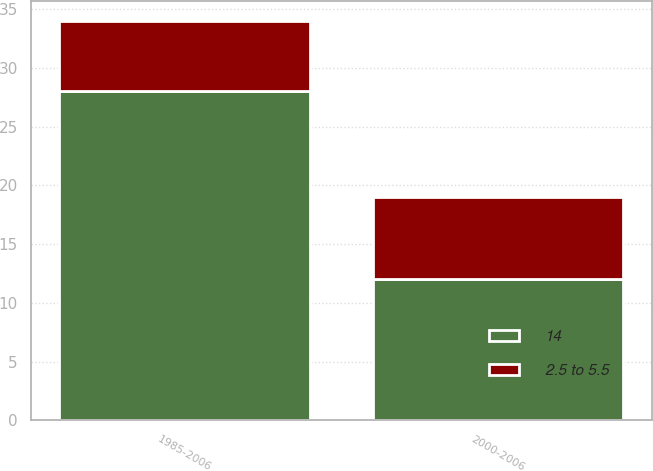Convert chart. <chart><loc_0><loc_0><loc_500><loc_500><stacked_bar_chart><ecel><fcel>1985-2006<fcel>2000-2006<nl><fcel>2.5 to 5.5<fcel>6<fcel>7<nl><fcel>14<fcel>28<fcel>12<nl></chart> 